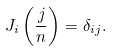<formula> <loc_0><loc_0><loc_500><loc_500>J _ { i } \left ( \frac { j } { n } \right ) = \delta _ { i j } .</formula> 